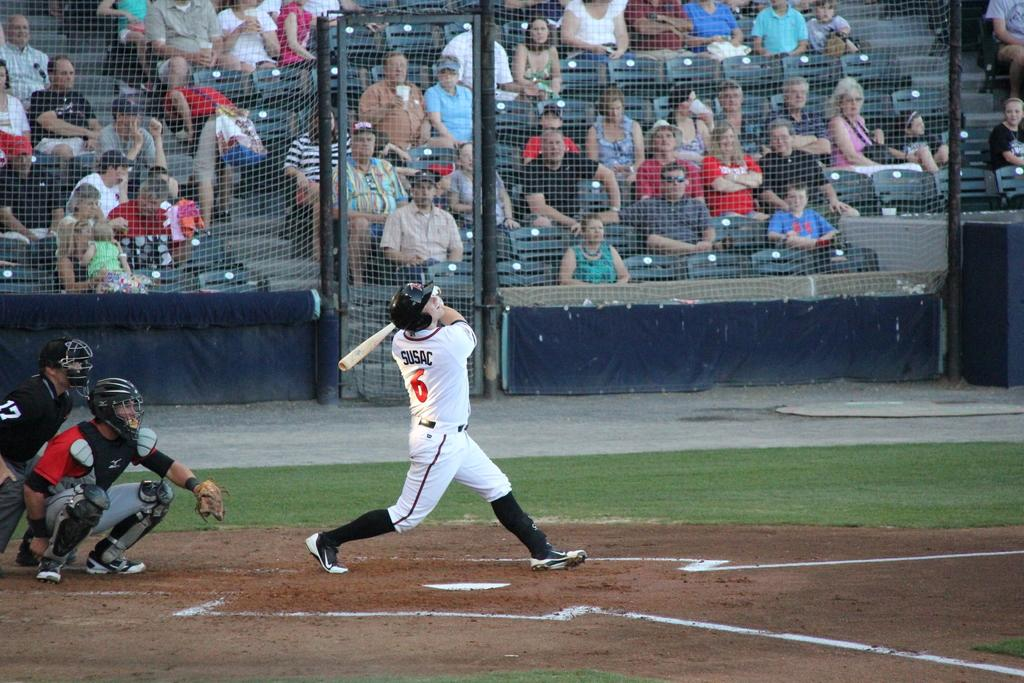<image>
Give a short and clear explanation of the subsequent image. Baseball player Susac at the batting plate hitting the baseball. 